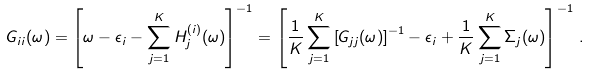Convert formula to latex. <formula><loc_0><loc_0><loc_500><loc_500>G _ { i i } ( \omega ) = \left [ \omega - \epsilon _ { i } - \sum _ { j = 1 } ^ { K } H ^ { ( i ) } _ { j } ( \omega ) \right ] ^ { - 1 } = \left [ \frac { 1 } { K } \sum _ { j = 1 } ^ { K } \left [ G _ { j j } ( \omega ) \right ] ^ { - 1 } - \epsilon _ { i } + \frac { 1 } { K } \sum _ { j = 1 } ^ { K } \Sigma _ { j } ( \omega ) \right ] ^ { - 1 } \, .</formula> 